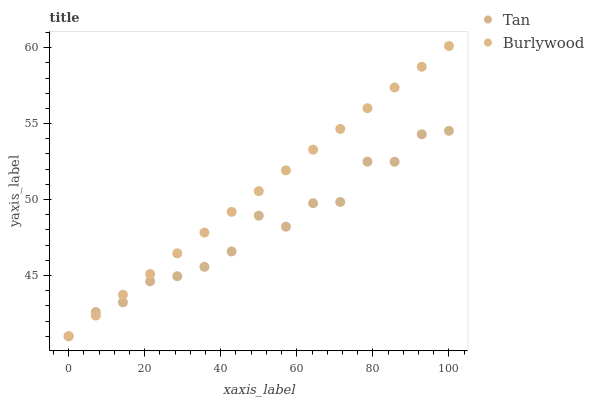Does Tan have the minimum area under the curve?
Answer yes or no. Yes. Does Burlywood have the maximum area under the curve?
Answer yes or no. Yes. Does Tan have the maximum area under the curve?
Answer yes or no. No. Is Burlywood the smoothest?
Answer yes or no. Yes. Is Tan the roughest?
Answer yes or no. Yes. Is Tan the smoothest?
Answer yes or no. No. Does Burlywood have the lowest value?
Answer yes or no. Yes. Does Burlywood have the highest value?
Answer yes or no. Yes. Does Tan have the highest value?
Answer yes or no. No. Does Burlywood intersect Tan?
Answer yes or no. Yes. Is Burlywood less than Tan?
Answer yes or no. No. Is Burlywood greater than Tan?
Answer yes or no. No. 